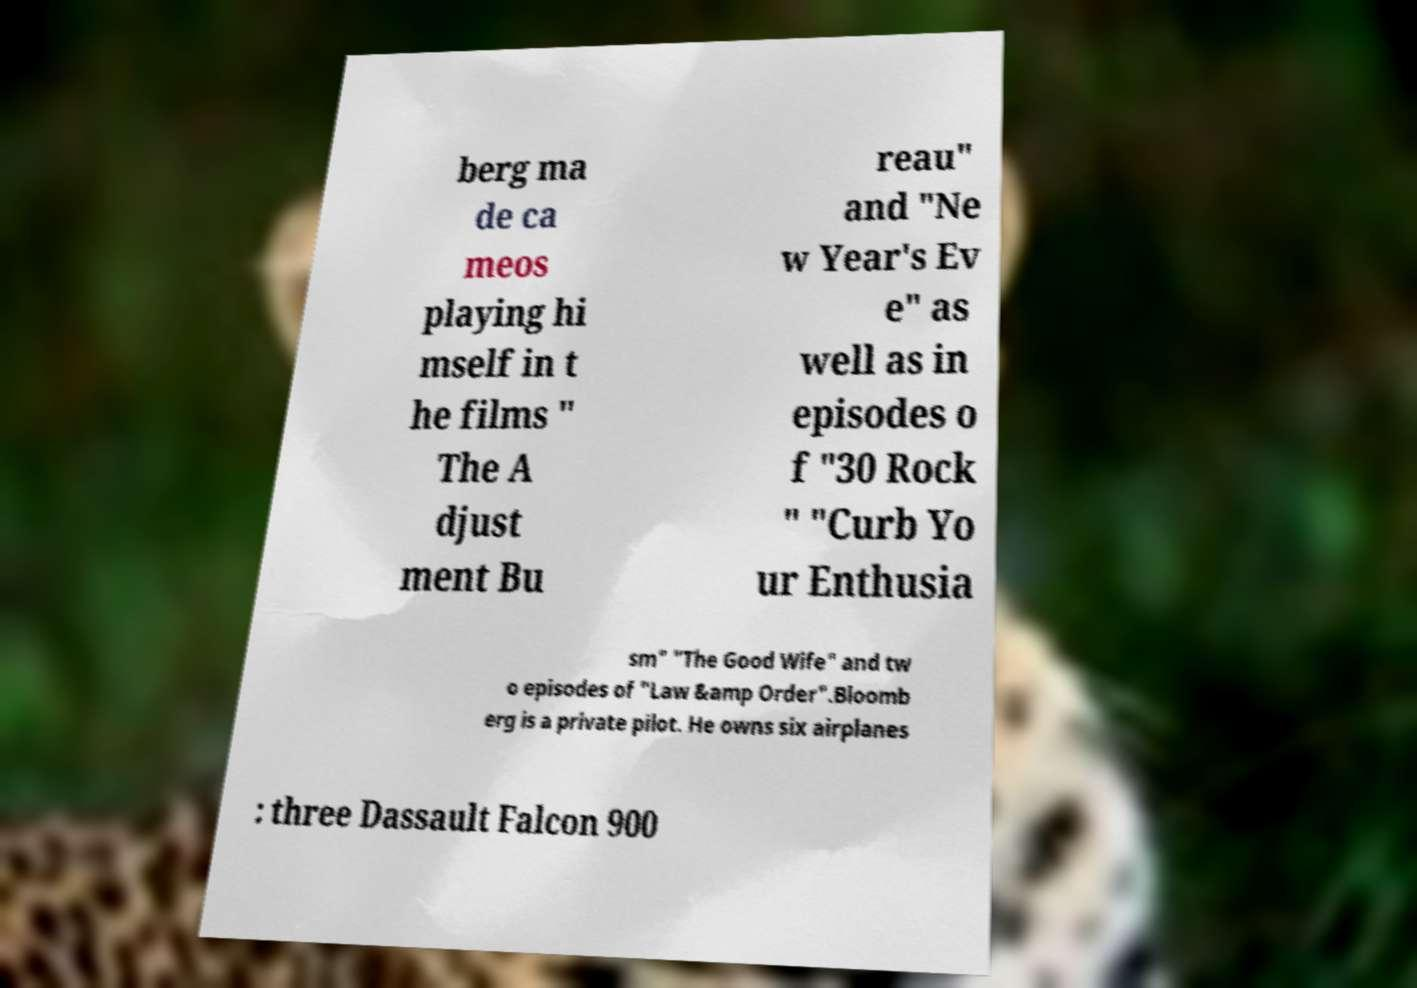What messages or text are displayed in this image? I need them in a readable, typed format. berg ma de ca meos playing hi mself in t he films " The A djust ment Bu reau" and "Ne w Year's Ev e" as well as in episodes o f "30 Rock " "Curb Yo ur Enthusia sm" "The Good Wife" and tw o episodes of "Law &amp Order".Bloomb erg is a private pilot. He owns six airplanes : three Dassault Falcon 900 